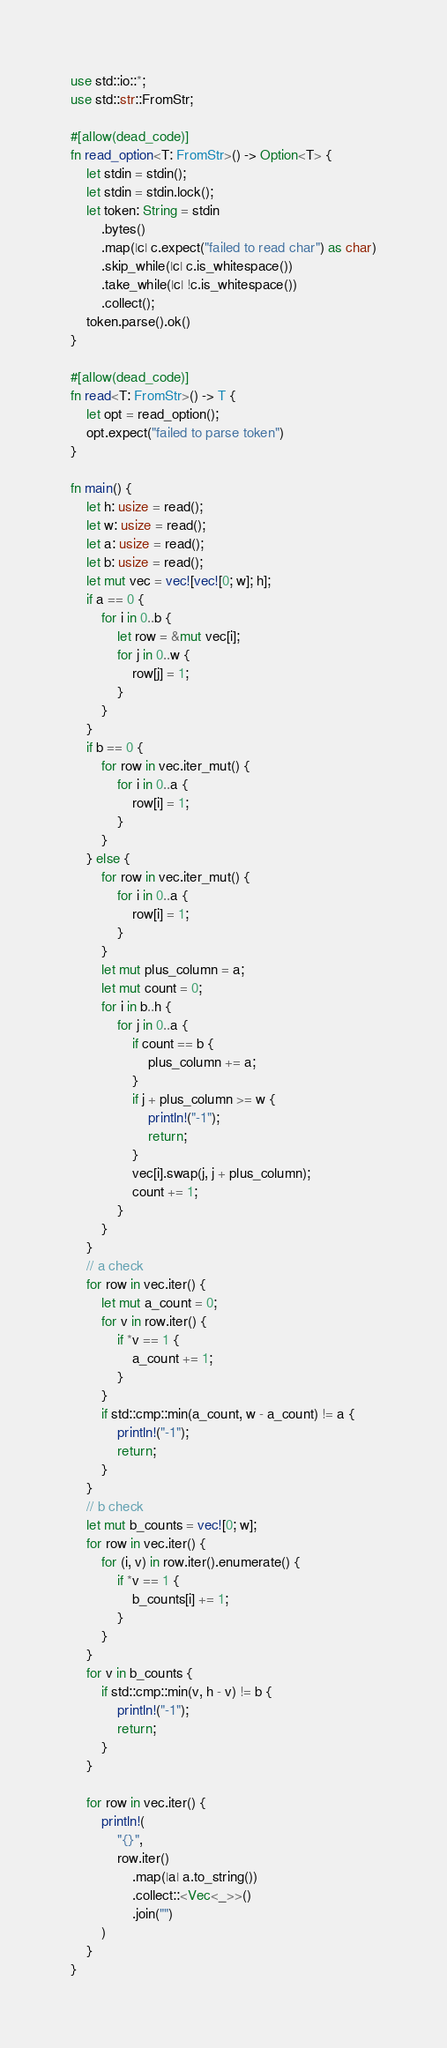Convert code to text. <code><loc_0><loc_0><loc_500><loc_500><_Rust_>use std::io::*;
use std::str::FromStr;

#[allow(dead_code)]
fn read_option<T: FromStr>() -> Option<T> {
    let stdin = stdin();
    let stdin = stdin.lock();
    let token: String = stdin
        .bytes()
        .map(|c| c.expect("failed to read char") as char)
        .skip_while(|c| c.is_whitespace())
        .take_while(|c| !c.is_whitespace())
        .collect();
    token.parse().ok()
}

#[allow(dead_code)]
fn read<T: FromStr>() -> T {
    let opt = read_option();
    opt.expect("failed to parse token")
}

fn main() {
    let h: usize = read();
    let w: usize = read();
    let a: usize = read();
    let b: usize = read();
    let mut vec = vec![vec![0; w]; h];
    if a == 0 {
        for i in 0..b {
            let row = &mut vec[i];
            for j in 0..w {
                row[j] = 1;
            }
        }
    }
    if b == 0 {
        for row in vec.iter_mut() {
            for i in 0..a {
                row[i] = 1;
            }
        }
    } else {
        for row in vec.iter_mut() {
            for i in 0..a {
                row[i] = 1;
            }
        }
        let mut plus_column = a;
        let mut count = 0;
        for i in b..h {
            for j in 0..a {
                if count == b {
                    plus_column += a;
                }
                if j + plus_column >= w {
                    println!("-1");
                    return;
                }
                vec[i].swap(j, j + plus_column);
                count += 1;
            }
        }
    }
    // a check
    for row in vec.iter() {
        let mut a_count = 0;
        for v in row.iter() {
            if *v == 1 {
                a_count += 1;
            }
        }
        if std::cmp::min(a_count, w - a_count) != a {
            println!("-1");
            return;
        }
    }
    // b check
    let mut b_counts = vec![0; w];
    for row in vec.iter() {
        for (i, v) in row.iter().enumerate() {
            if *v == 1 {
                b_counts[i] += 1;
            }
        }
    }
    for v in b_counts {
        if std::cmp::min(v, h - v) != b {
            println!("-1");
            return;
        }
    }

    for row in vec.iter() {
        println!(
            "{}",
            row.iter()
                .map(|a| a.to_string())
                .collect::<Vec<_>>()
                .join("")
        )
    }
}
</code> 